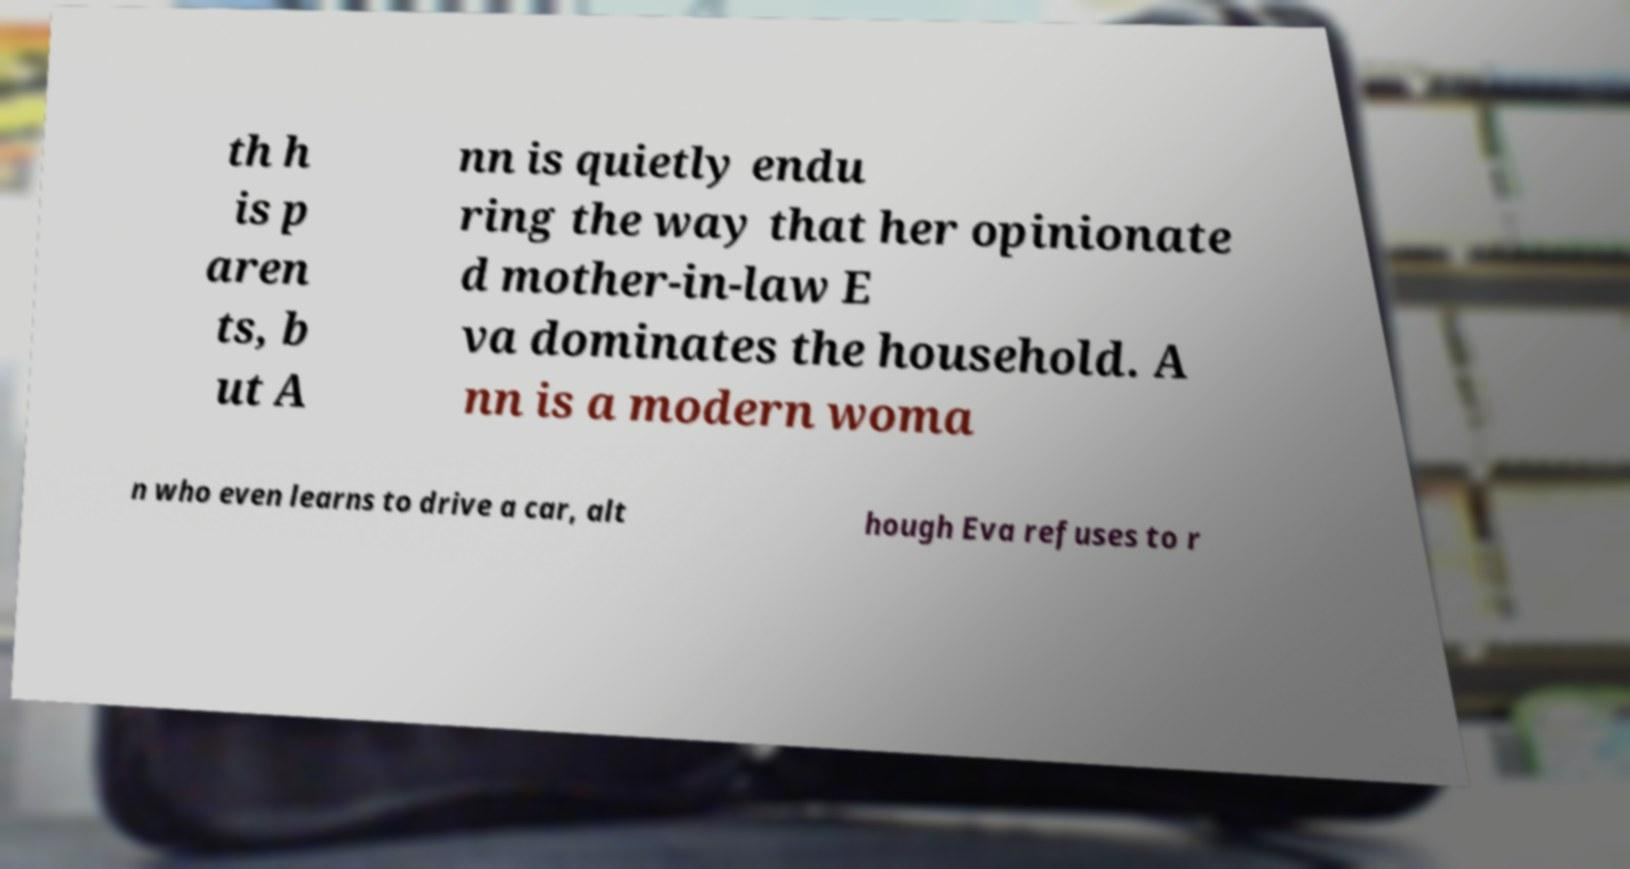What messages or text are displayed in this image? I need them in a readable, typed format. th h is p aren ts, b ut A nn is quietly endu ring the way that her opinionate d mother-in-law E va dominates the household. A nn is a modern woma n who even learns to drive a car, alt hough Eva refuses to r 